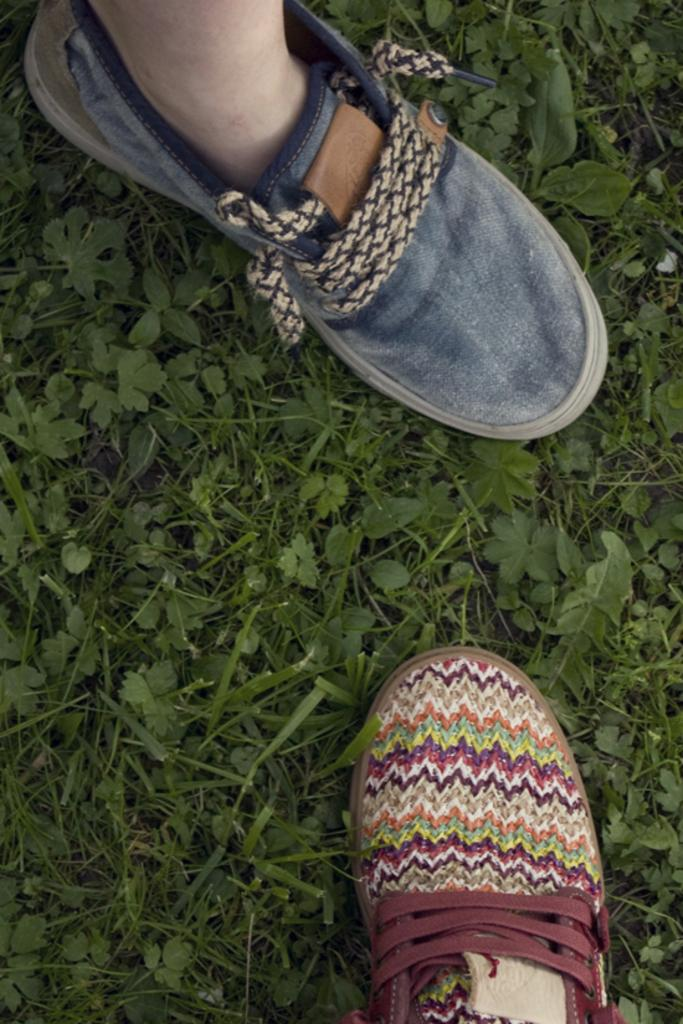What body part is visible in the image? There is a person's foot in the image. What is placed on the ground in the image? There is a shoe placed on the ground in the image. What type of bottle is being worn by the person in the image? There is no bottle present in the image; it only shows a person's foot and a shoe on the ground. 